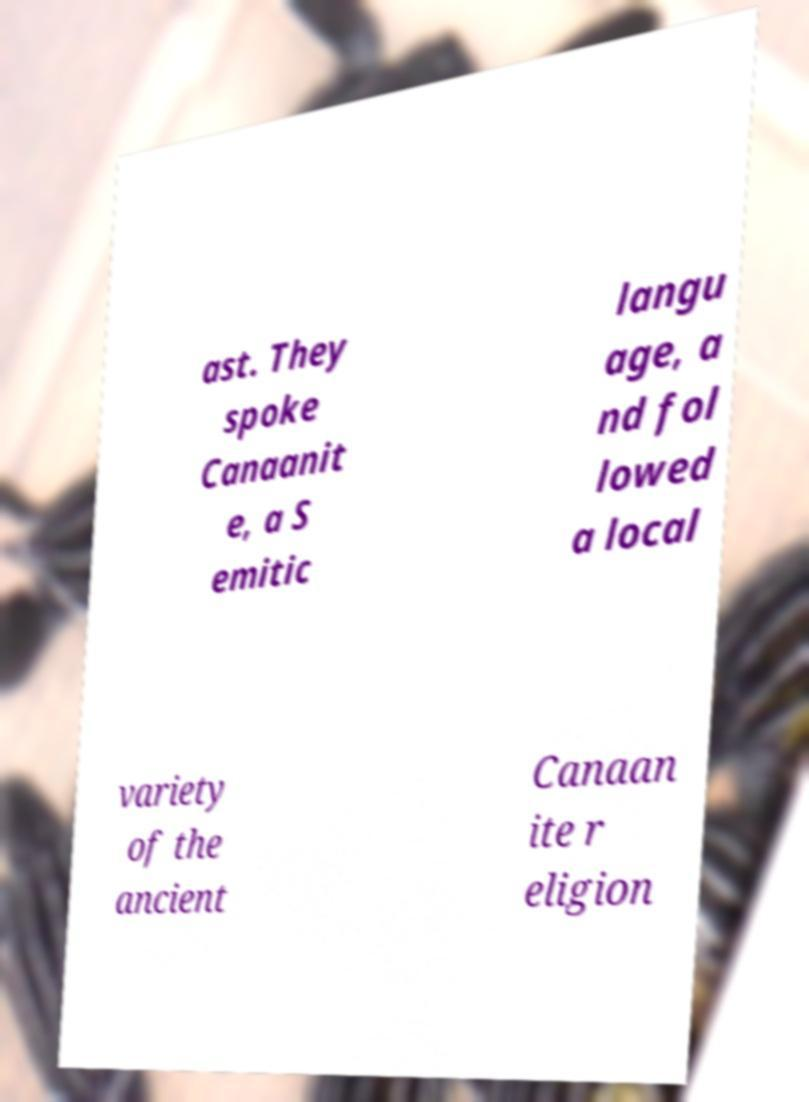Please read and relay the text visible in this image. What does it say? ast. They spoke Canaanit e, a S emitic langu age, a nd fol lowed a local variety of the ancient Canaan ite r eligion 